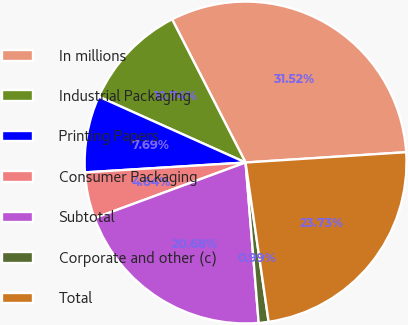<chart> <loc_0><loc_0><loc_500><loc_500><pie_chart><fcel>In millions<fcel>Industrial Packaging<fcel>Printing Papers<fcel>Consumer Packaging<fcel>Subtotal<fcel>Corporate and other (c)<fcel>Total<nl><fcel>31.52%<fcel>10.74%<fcel>7.69%<fcel>4.64%<fcel>20.68%<fcel>0.99%<fcel>23.73%<nl></chart> 